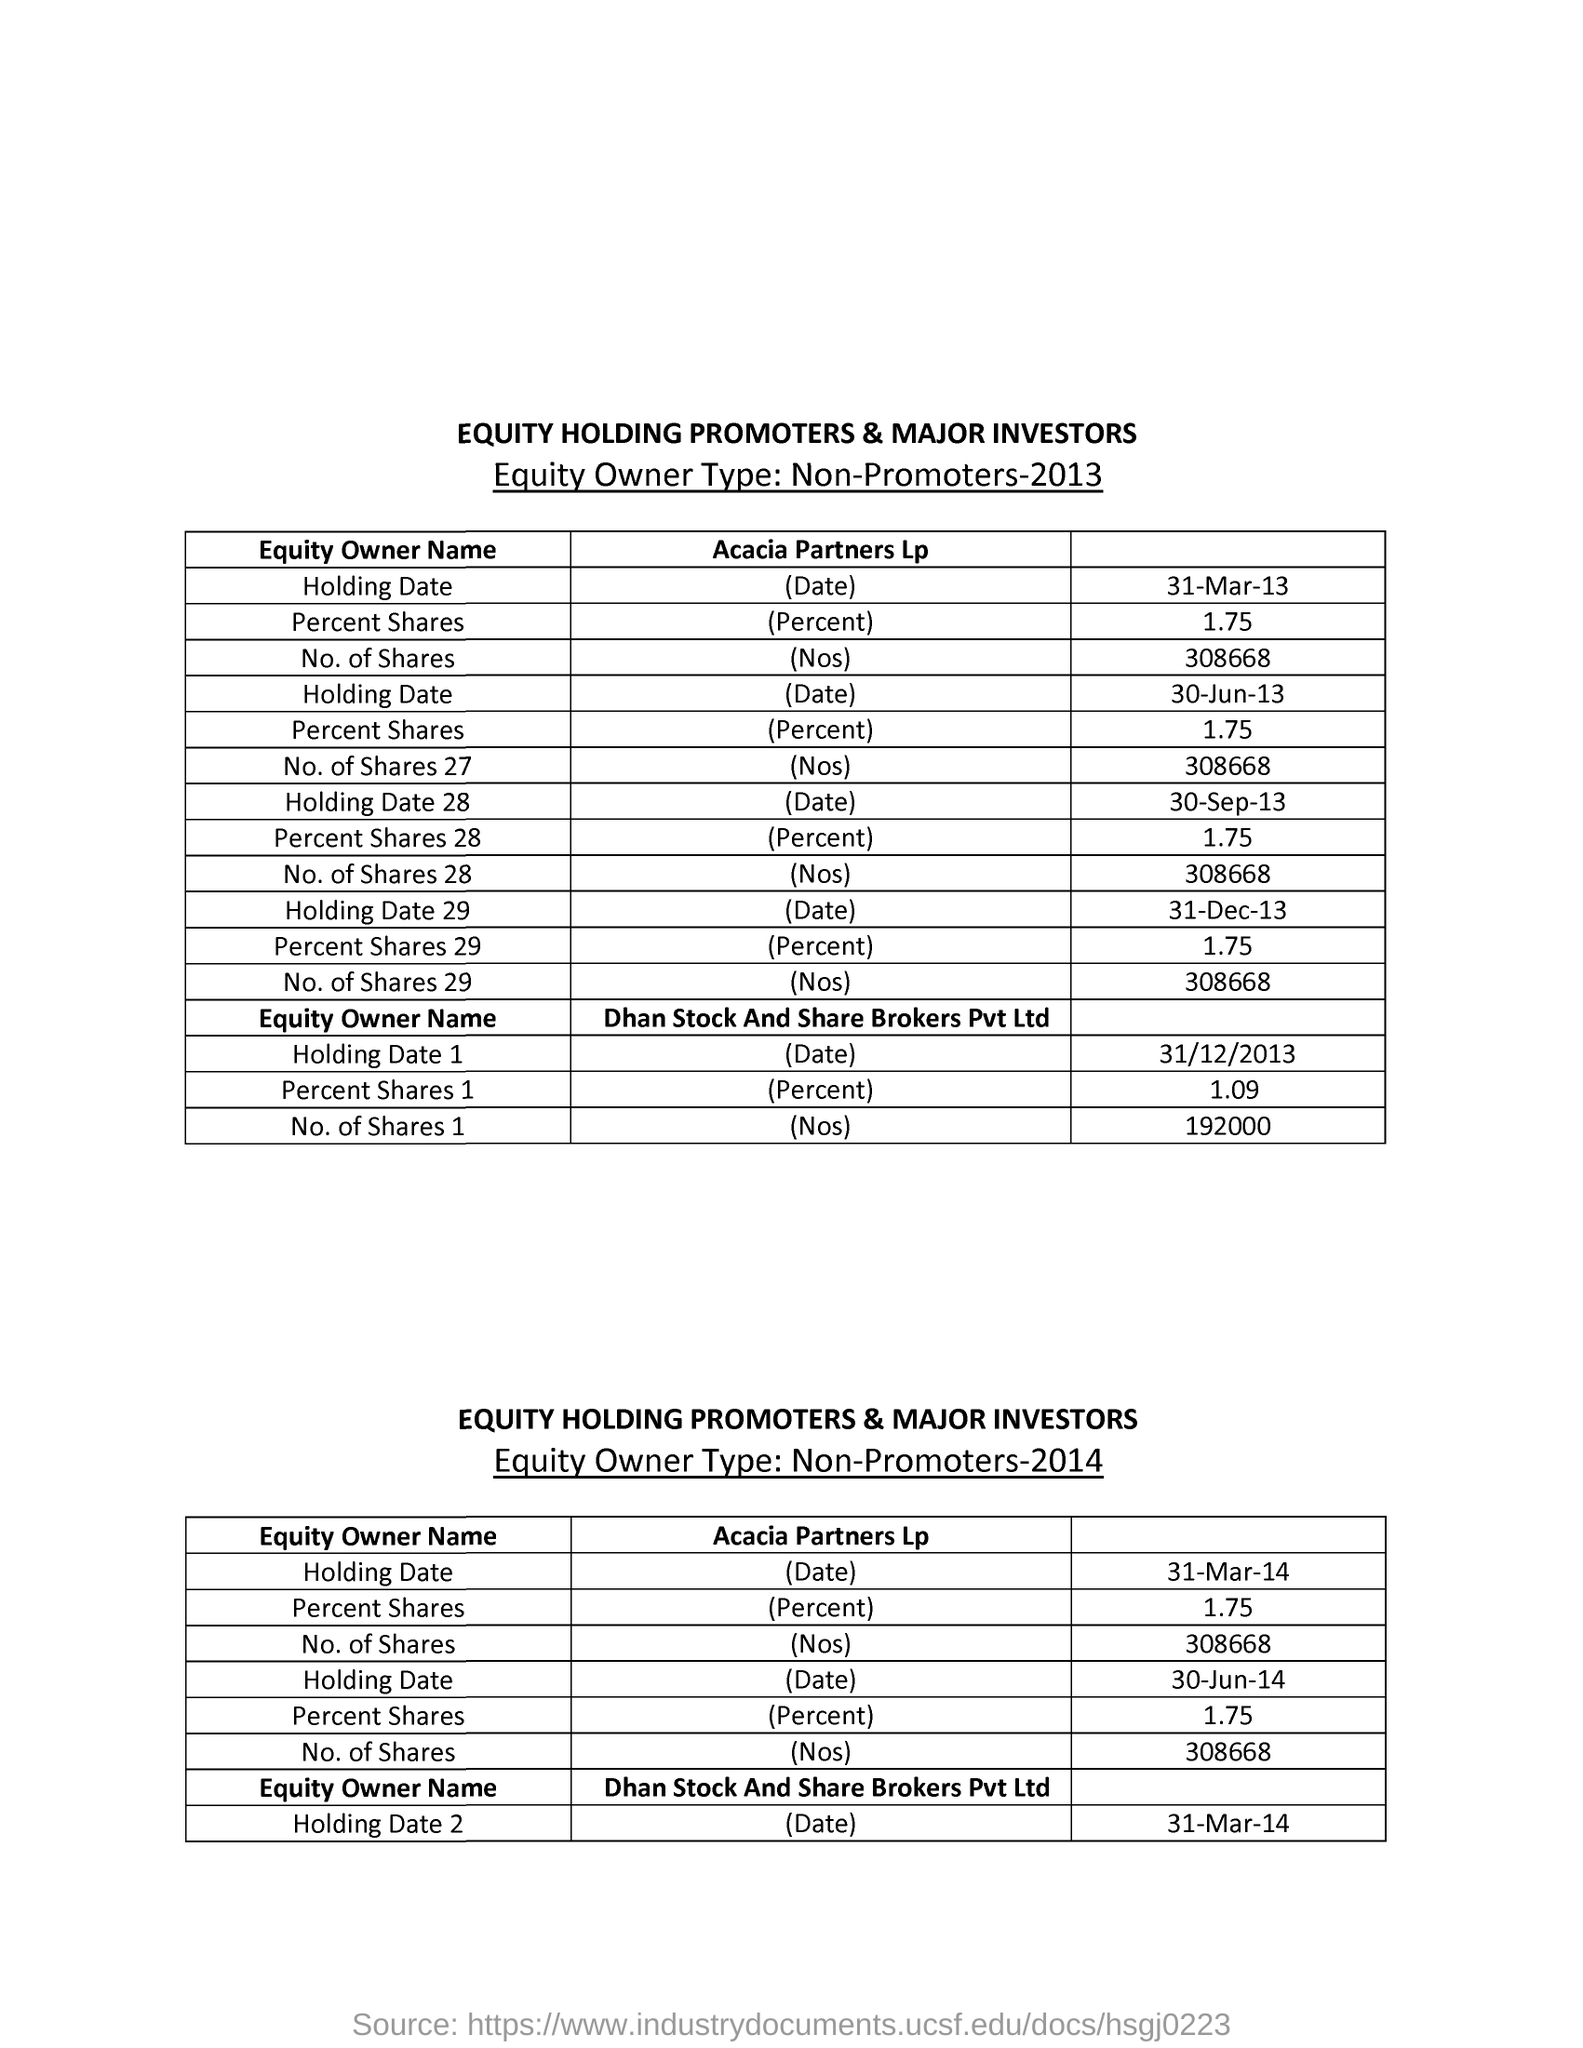Identify some key points in this picture. The table title is "What is the table title? EQUITY HOLDING PROMOTERS & MAJOR INVESTORS.. The equity owner type is non-promoters. 